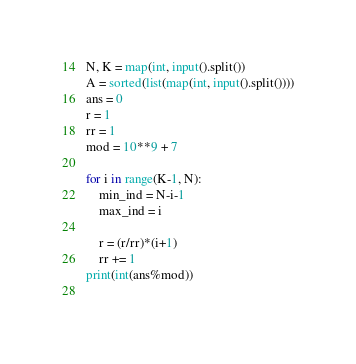<code> <loc_0><loc_0><loc_500><loc_500><_Python_>N, K = map(int, input().split())
A = sorted(list(map(int, input().split())))
ans = 0
r = 1
rr = 1
mod = 10**9 + 7

for i in range(K-1, N):
    min_ind = N-i-1
    max_ind = i

    r = (r/rr)*(i+1)
    rr += 1
print(int(ans%mod))
    </code> 